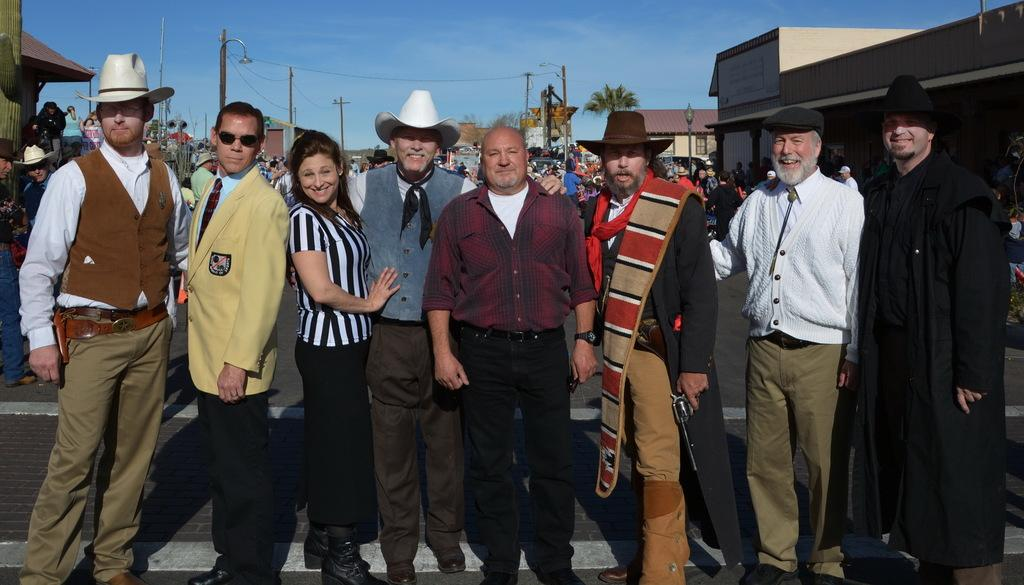How many people are in the image? There is a group of people in the image. What are the people doing in the image? The people are standing. What can be observed about the clothing of the people in the image? The people are wearing different color dresses. What type of structures can be seen in the image? There are buildings in the image. What are some other objects visible in the image? Light-poles, wires, poles, trees, and the sky are visible in the image. What type of throat treatment is being administered to the partner in the image? There is no indication of a throat treatment or a partner in the image. 